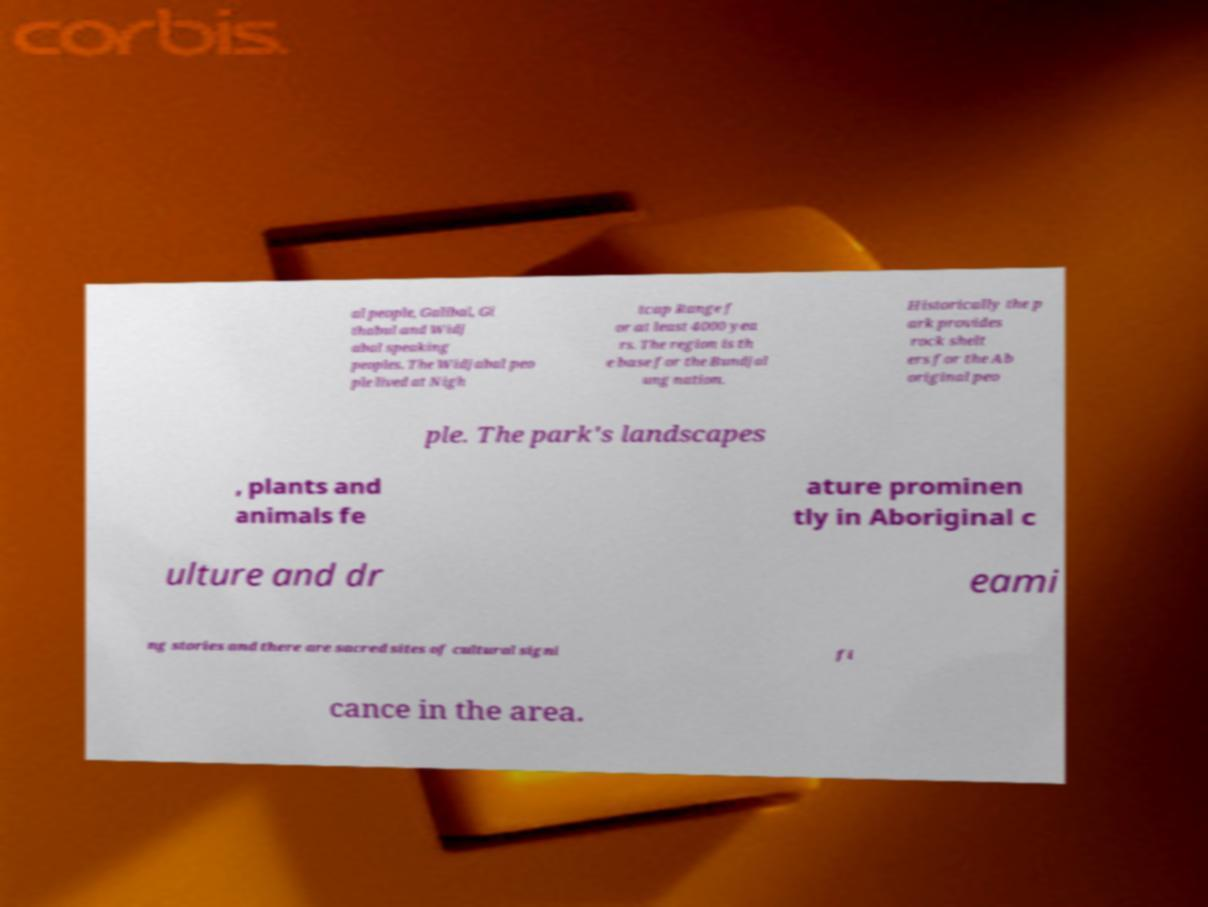Please read and relay the text visible in this image. What does it say? al people, Galibal, Gi thabul and Widj abal speaking peoples. The Widjabal peo ple lived at Nigh tcap Range f or at least 4000 yea rs. The region is th e base for the Bundjal ung nation. Historically the p ark provides rock shelt ers for the Ab original peo ple. The park's landscapes , plants and animals fe ature prominen tly in Aboriginal c ulture and dr eami ng stories and there are sacred sites of cultural signi fi cance in the area. 